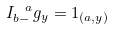Convert formula to latex. <formula><loc_0><loc_0><loc_500><loc_500>I _ { b - } ^ { \ a } g _ { y } = 1 _ { ( a , y ) }</formula> 